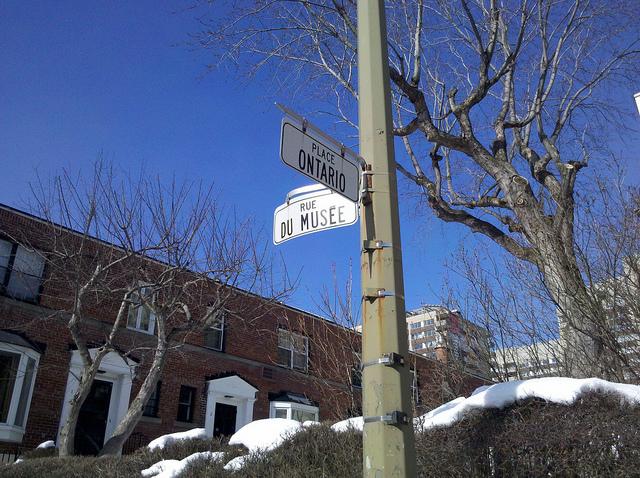Is the name of this street one used by several entities?
Short answer required. Yes. What season is it?
Concise answer only. Winter. Are the trees bare?
Write a very short answer. Yes. 